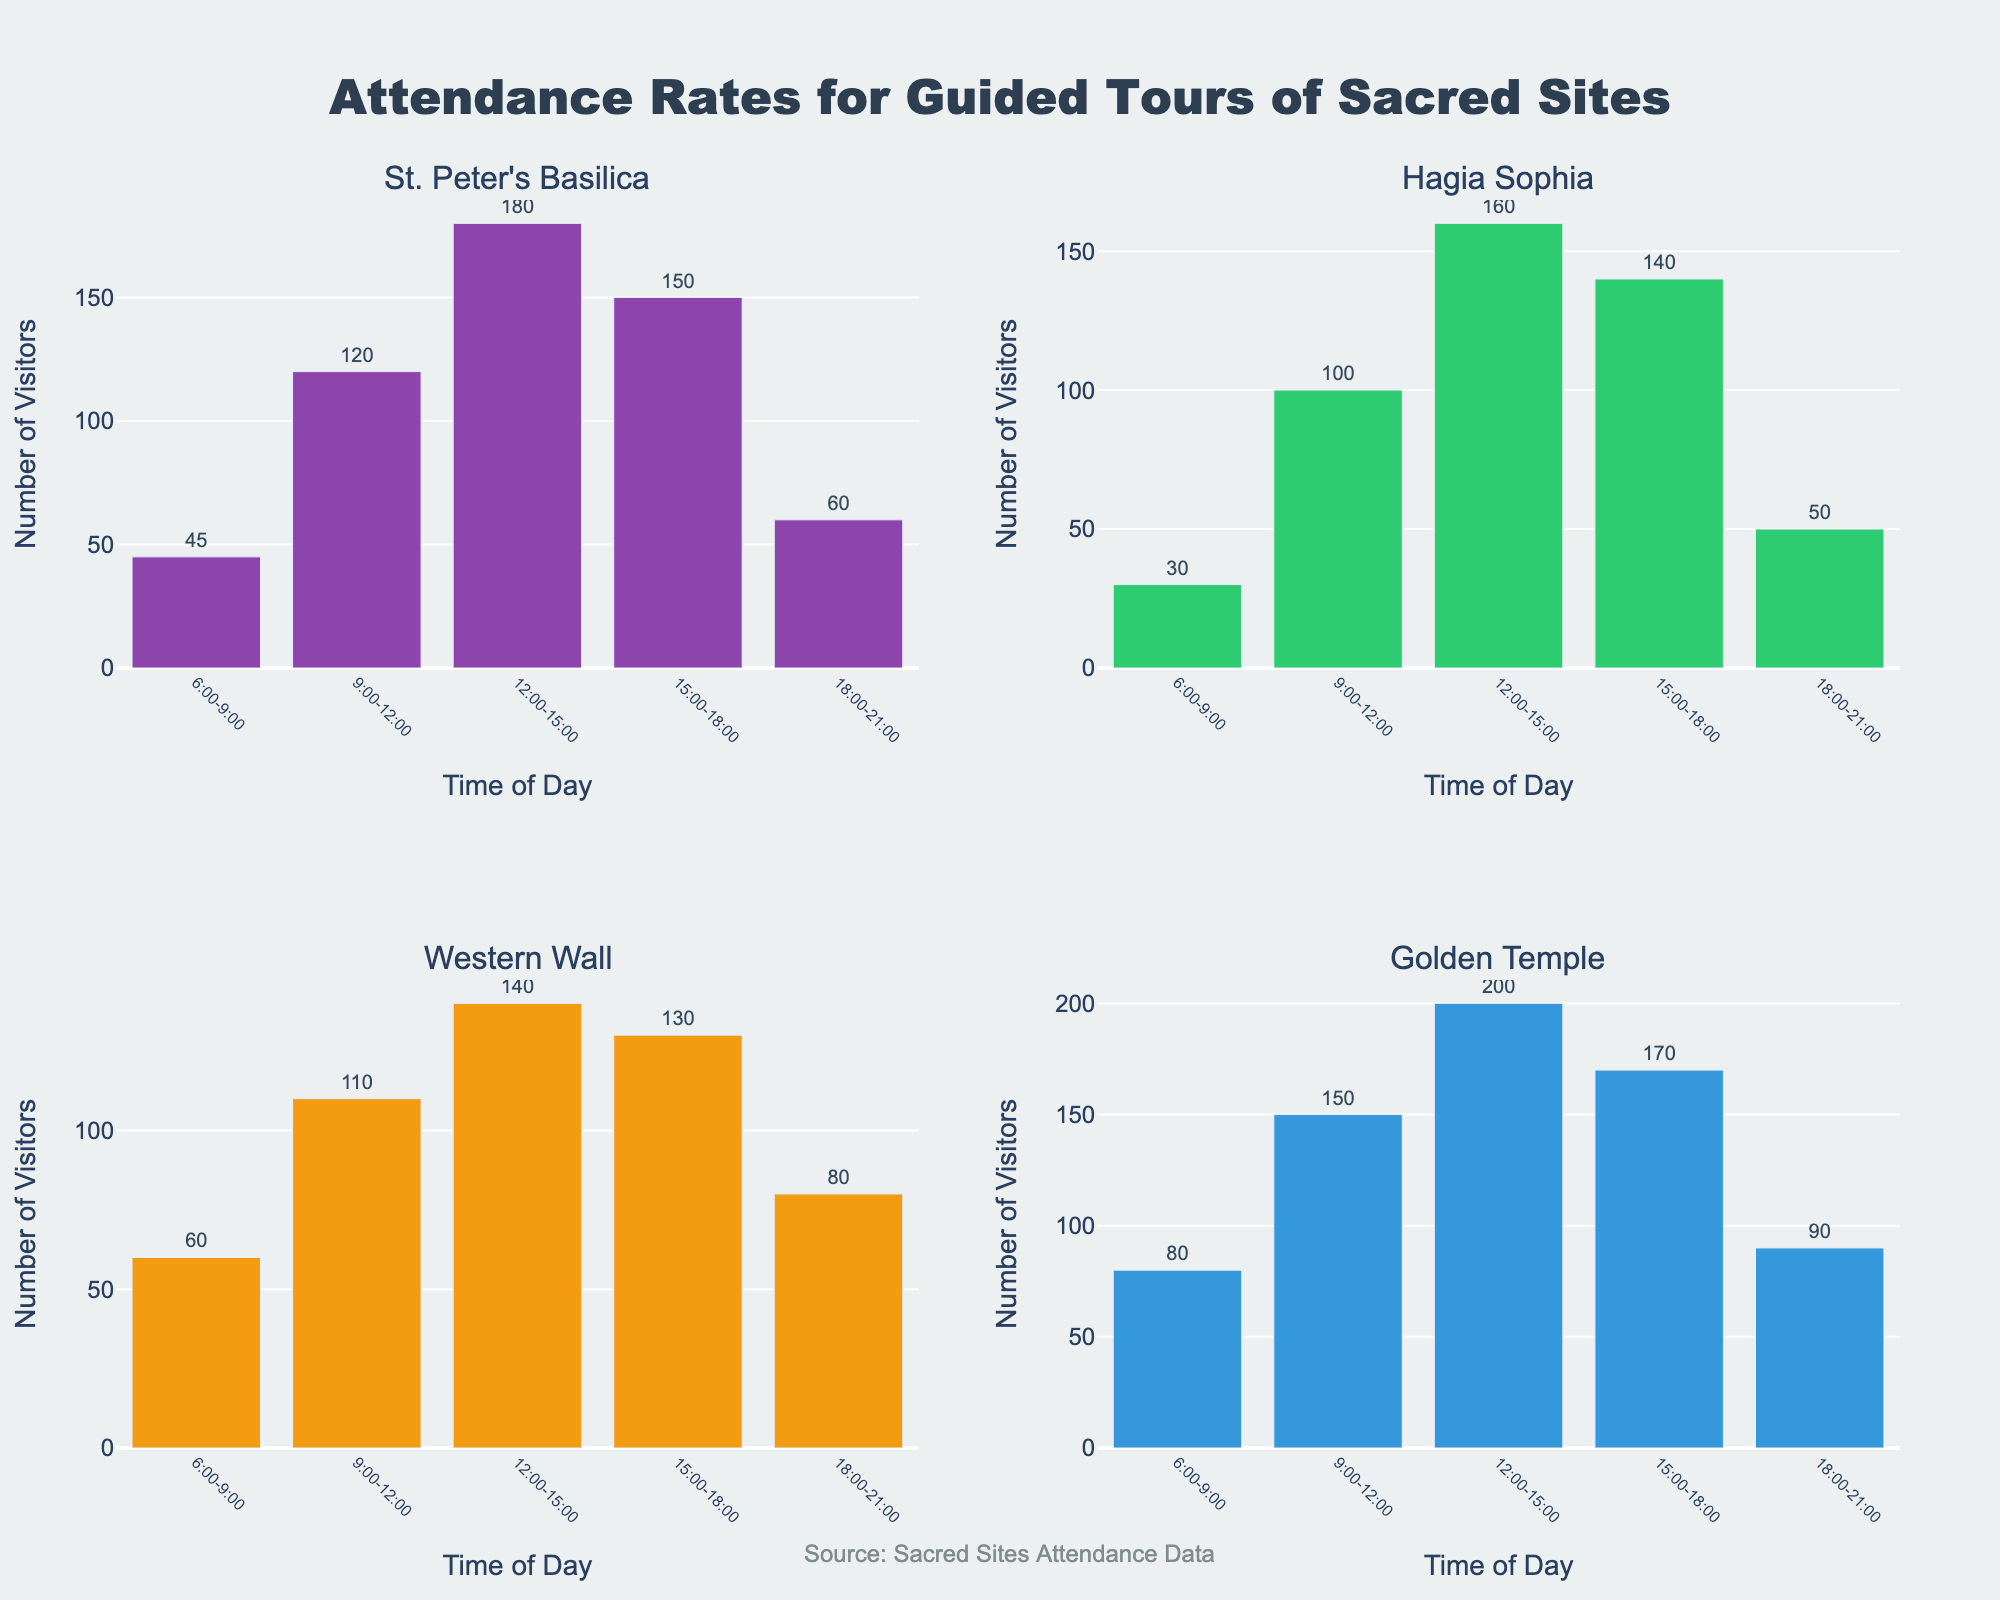Which sacred site has the highest number of visitors in the 12:00-15:00 time slot? First, looking at the 12:00-15:00 time slot for each subplot, St. Peter's Basilica and Golden Temple have 180 and 200 visitors respectively. Comparing these values, the Golden Temple has the highest number of visitors.
Answer: Golden Temple At what time of day does the Western Wall have the fewest visitors? For the Western Wall subplot, the visitor counts by time of day are as follows: 60 (6:00-9:00), 110 (9:00-12:00), 140 (12:00-15:00), 130 (15:00-18:00), and 80 (18:00-21:00). The fewest visitors are during the 6:00-9:00 time slot.
Answer: 6:00-9:00 Which time slot generally shows the largest variation in the number of visitors across all sites? By observing all the subplots corresponding to each time slot, you’ll notice the widest range of the number of visitors is during the 12:00-15:00 slot: 180 (St. Peter's Basilica), 160 (Hagia Sophia), 140 (Western Wall), and 200 (Golden Temple). This slot shows the largest variation.
Answer: 12:00-15:00 How many more visitors does St. Peter's Basilica have than Hagia Sophia in the 15:00-18:00 time slot? St. Peter's Basilica receives 150 visitors and Hagia Sophia receives 140 visitors in that time slot. The difference is calculated by 150 - 140.
Answer: 10 Which time slot consistently attracts the highest number of visitors across all sacred sites? By scanning each subplot, the time slot 12:00-15:00 consistently has the highest number of visitors across all sites: 180 (St. Peter's Basilica), 160 (Hagia Sophia), 140 (Western Wall), and 200 (Golden Temple).
Answer: 12:00-15:00 What is the total number of visitors to St. Peter's Basilica throughout the day? For St. Peter's Basilica, sum the visitor counts: 45 (6:00-9:00) + 120 (9:00-12:00) + 180 (12:00-15:00) + 150 (15:00-18:00) + 60 (18:00-21:00) = 555.
Answer: 555 In which time slot does Hagia Sophia have exactly 50 visitors? From the Hagia Sophia subplot, the 18:00-21:00 time slot shows Hagia Sophia getting exactly 50 visitors.
Answer: 18:00-21:00 How does the number of visitors to the Golden Temple in the 6:00-9:00 time slot compare to the number of visitors to the Western Wall in the same time slot? Golden Temple has 80 visitors during 6:00-9:00, while the Western Wall has 60 visitors in that same time slot. The Golden Temple has more visitors.
Answer: Golden Temple has more visitors 